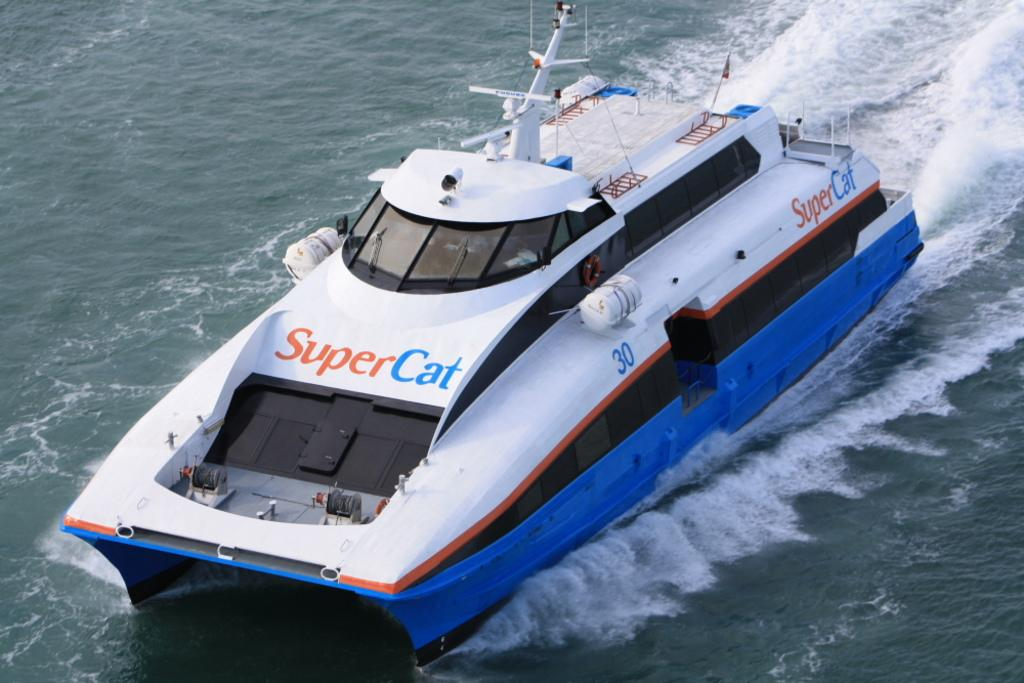<image>
Give a short and clear explanation of the subsequent image. The name of the blue and white boat is Super Cat. 